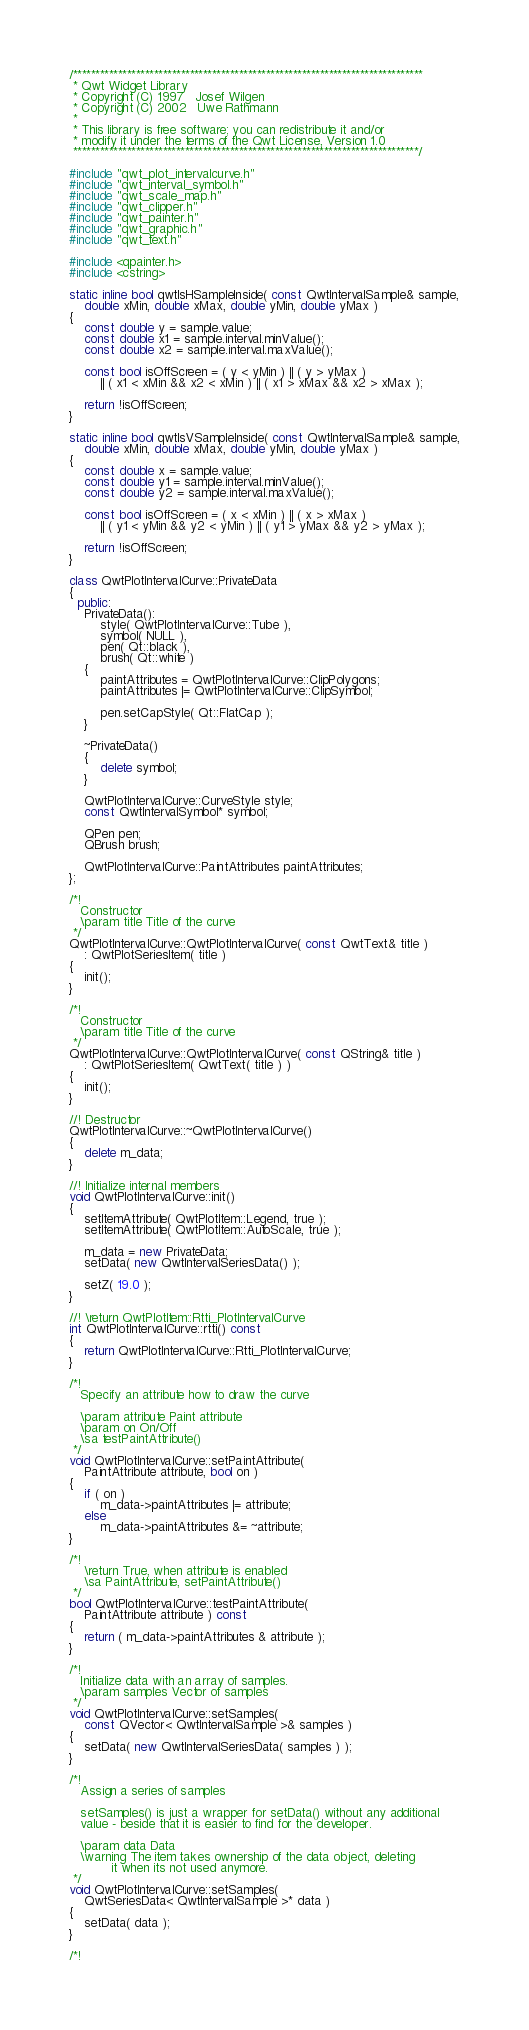Convert code to text. <code><loc_0><loc_0><loc_500><loc_500><_C++_>/******************************************************************************
 * Qwt Widget Library
 * Copyright (C) 1997   Josef Wilgen
 * Copyright (C) 2002   Uwe Rathmann
 *
 * This library is free software; you can redistribute it and/or
 * modify it under the terms of the Qwt License, Version 1.0
 *****************************************************************************/

#include "qwt_plot_intervalcurve.h"
#include "qwt_interval_symbol.h"
#include "qwt_scale_map.h"
#include "qwt_clipper.h"
#include "qwt_painter.h"
#include "qwt_graphic.h"
#include "qwt_text.h"

#include <qpainter.h>
#include <cstring>

static inline bool qwtIsHSampleInside( const QwtIntervalSample& sample,
    double xMin, double xMax, double yMin, double yMax )
{
    const double y = sample.value;
    const double x1 = sample.interval.minValue();
    const double x2 = sample.interval.maxValue();

    const bool isOffScreen = ( y < yMin ) || ( y > yMax )
        || ( x1 < xMin && x2 < xMin ) || ( x1 > xMax && x2 > xMax );

    return !isOffScreen;
}

static inline bool qwtIsVSampleInside( const QwtIntervalSample& sample,
    double xMin, double xMax, double yMin, double yMax )
{
    const double x = sample.value;
    const double y1 = sample.interval.minValue();
    const double y2 = sample.interval.maxValue();

    const bool isOffScreen = ( x < xMin ) || ( x > xMax )
        || ( y1 < yMin && y2 < yMin ) || ( y1 > yMax && y2 > yMax );

    return !isOffScreen;
}

class QwtPlotIntervalCurve::PrivateData
{
  public:
    PrivateData():
        style( QwtPlotIntervalCurve::Tube ),
        symbol( NULL ),
        pen( Qt::black ),
        brush( Qt::white )
    {
        paintAttributes = QwtPlotIntervalCurve::ClipPolygons;
        paintAttributes |= QwtPlotIntervalCurve::ClipSymbol;

        pen.setCapStyle( Qt::FlatCap );
    }

    ~PrivateData()
    {
        delete symbol;
    }

    QwtPlotIntervalCurve::CurveStyle style;
    const QwtIntervalSymbol* symbol;

    QPen pen;
    QBrush brush;

    QwtPlotIntervalCurve::PaintAttributes paintAttributes;
};

/*!
   Constructor
   \param title Title of the curve
 */
QwtPlotIntervalCurve::QwtPlotIntervalCurve( const QwtText& title )
    : QwtPlotSeriesItem( title )
{
    init();
}

/*!
   Constructor
   \param title Title of the curve
 */
QwtPlotIntervalCurve::QwtPlotIntervalCurve( const QString& title )
    : QwtPlotSeriesItem( QwtText( title ) )
{
    init();
}

//! Destructor
QwtPlotIntervalCurve::~QwtPlotIntervalCurve()
{
    delete m_data;
}

//! Initialize internal members
void QwtPlotIntervalCurve::init()
{
    setItemAttribute( QwtPlotItem::Legend, true );
    setItemAttribute( QwtPlotItem::AutoScale, true );

    m_data = new PrivateData;
    setData( new QwtIntervalSeriesData() );

    setZ( 19.0 );
}

//! \return QwtPlotItem::Rtti_PlotIntervalCurve
int QwtPlotIntervalCurve::rtti() const
{
    return QwtPlotIntervalCurve::Rtti_PlotIntervalCurve;
}

/*!
   Specify an attribute how to draw the curve

   \param attribute Paint attribute
   \param on On/Off
   \sa testPaintAttribute()
 */
void QwtPlotIntervalCurve::setPaintAttribute(
    PaintAttribute attribute, bool on )
{
    if ( on )
        m_data->paintAttributes |= attribute;
    else
        m_data->paintAttributes &= ~attribute;
}

/*!
    \return True, when attribute is enabled
    \sa PaintAttribute, setPaintAttribute()
 */
bool QwtPlotIntervalCurve::testPaintAttribute(
    PaintAttribute attribute ) const
{
    return ( m_data->paintAttributes & attribute );
}

/*!
   Initialize data with an array of samples.
   \param samples Vector of samples
 */
void QwtPlotIntervalCurve::setSamples(
    const QVector< QwtIntervalSample >& samples )
{
    setData( new QwtIntervalSeriesData( samples ) );
}

/*!
   Assign a series of samples

   setSamples() is just a wrapper for setData() without any additional
   value - beside that it is easier to find for the developer.

   \param data Data
   \warning The item takes ownership of the data object, deleting
           it when its not used anymore.
 */
void QwtPlotIntervalCurve::setSamples(
    QwtSeriesData< QwtIntervalSample >* data )
{
    setData( data );
}

/*!</code> 